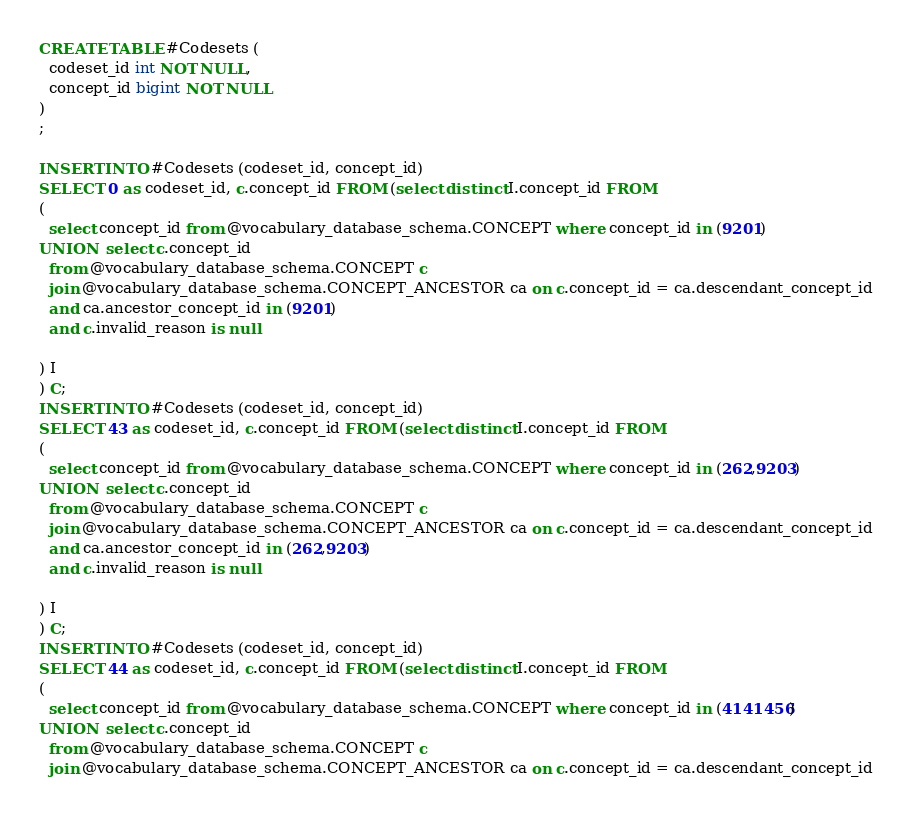Convert code to text. <code><loc_0><loc_0><loc_500><loc_500><_SQL_>CREATE TABLE #Codesets (
  codeset_id int NOT NULL,
  concept_id bigint NOT NULL
)
;

INSERT INTO #Codesets (codeset_id, concept_id)
SELECT 0 as codeset_id, c.concept_id FROM (select distinct I.concept_id FROM
( 
  select concept_id from @vocabulary_database_schema.CONCEPT where concept_id in (9201)
UNION  select c.concept_id
  from @vocabulary_database_schema.CONCEPT c
  join @vocabulary_database_schema.CONCEPT_ANCESTOR ca on c.concept_id = ca.descendant_concept_id
  and ca.ancestor_concept_id in (9201)
  and c.invalid_reason is null

) I
) C;
INSERT INTO #Codesets (codeset_id, concept_id)
SELECT 43 as codeset_id, c.concept_id FROM (select distinct I.concept_id FROM
( 
  select concept_id from @vocabulary_database_schema.CONCEPT where concept_id in (262,9203)
UNION  select c.concept_id
  from @vocabulary_database_schema.CONCEPT c
  join @vocabulary_database_schema.CONCEPT_ANCESTOR ca on c.concept_id = ca.descendant_concept_id
  and ca.ancestor_concept_id in (262,9203)
  and c.invalid_reason is null

) I
) C;
INSERT INTO #Codesets (codeset_id, concept_id)
SELECT 44 as codeset_id, c.concept_id FROM (select distinct I.concept_id FROM
( 
  select concept_id from @vocabulary_database_schema.CONCEPT where concept_id in (4141456)
UNION  select c.concept_id
  from @vocabulary_database_schema.CONCEPT c
  join @vocabulary_database_schema.CONCEPT_ANCESTOR ca on c.concept_id = ca.descendant_concept_id</code> 